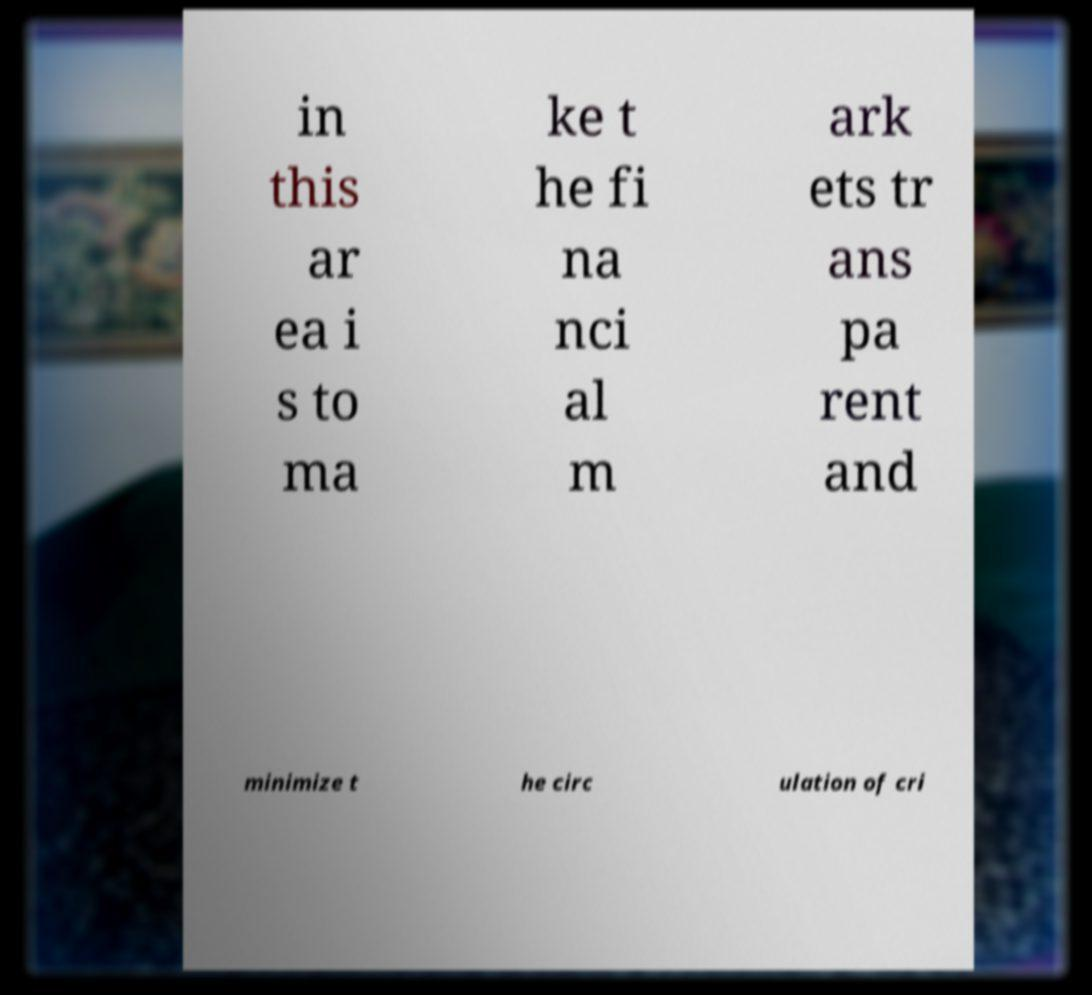Can you accurately transcribe the text from the provided image for me? in this ar ea i s to ma ke t he fi na nci al m ark ets tr ans pa rent and minimize t he circ ulation of cri 